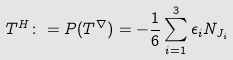<formula> <loc_0><loc_0><loc_500><loc_500>T ^ { H } \colon = P ( T ^ { \nabla } ) = - \frac { 1 } { 6 } \sum _ { i = 1 } ^ { 3 } \epsilon _ { i } N _ { J _ { i } }</formula> 